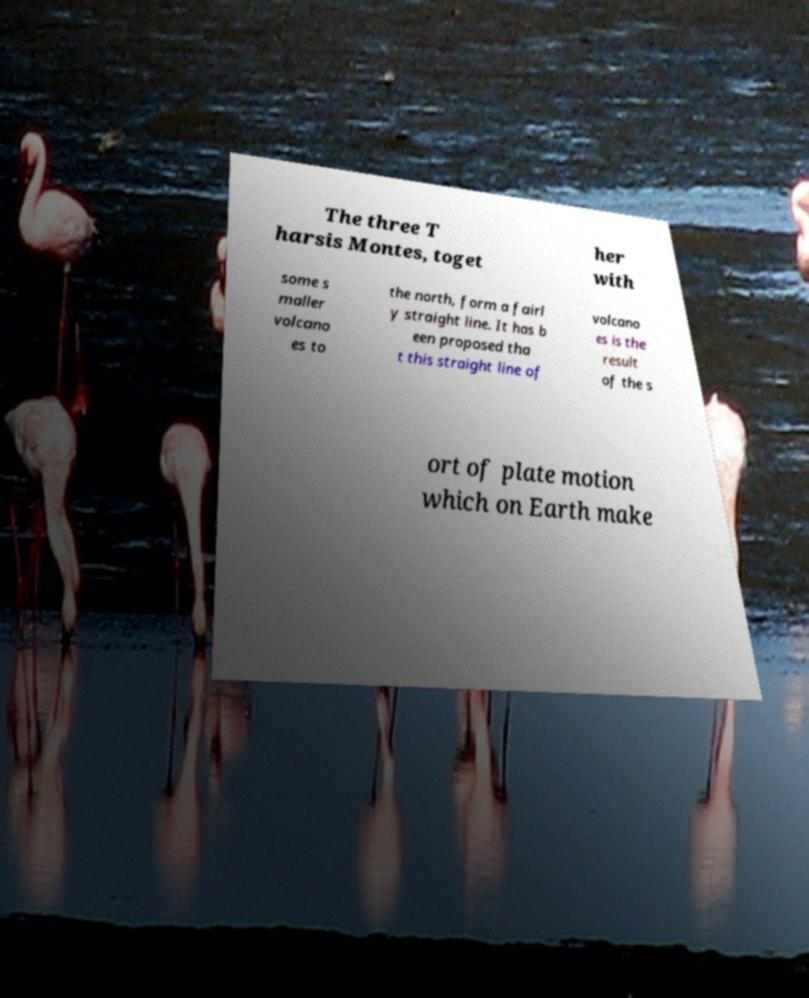Could you assist in decoding the text presented in this image and type it out clearly? The three T harsis Montes, toget her with some s maller volcano es to the north, form a fairl y straight line. It has b een proposed tha t this straight line of volcano es is the result of the s ort of plate motion which on Earth make 